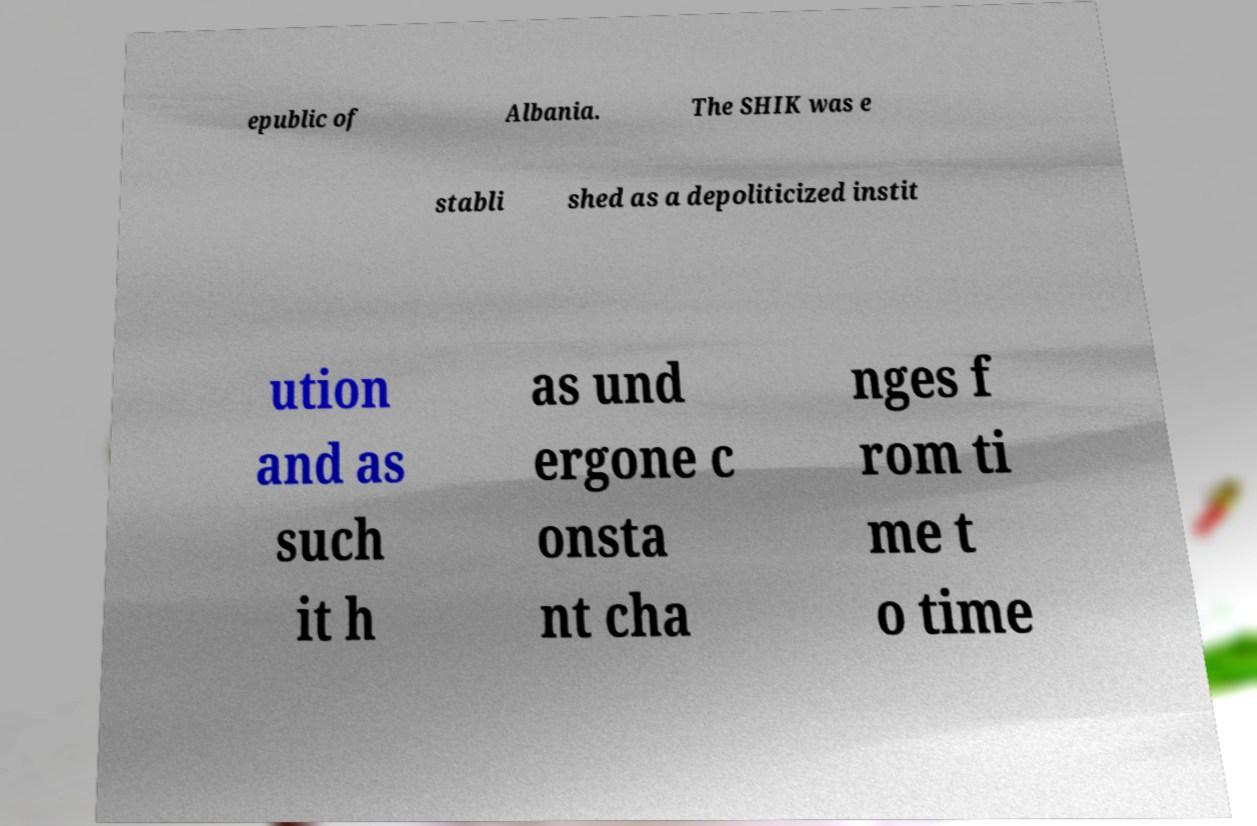Could you assist in decoding the text presented in this image and type it out clearly? epublic of Albania. The SHIK was e stabli shed as a depoliticized instit ution and as such it h as und ergone c onsta nt cha nges f rom ti me t o time 